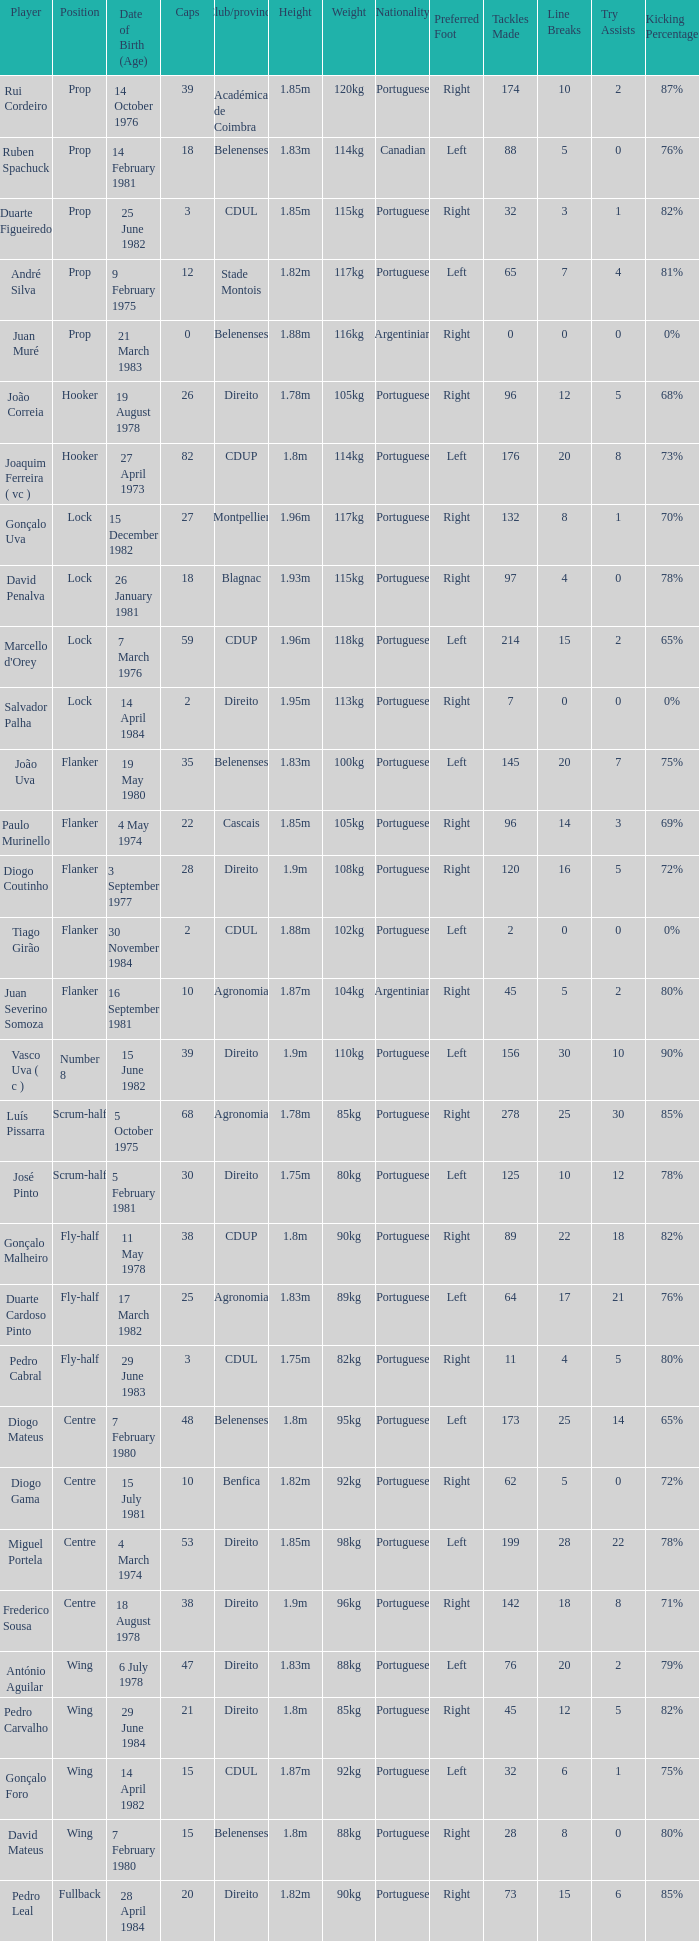How many caps have a Position of prop, and a Player of rui cordeiro? 1.0. 